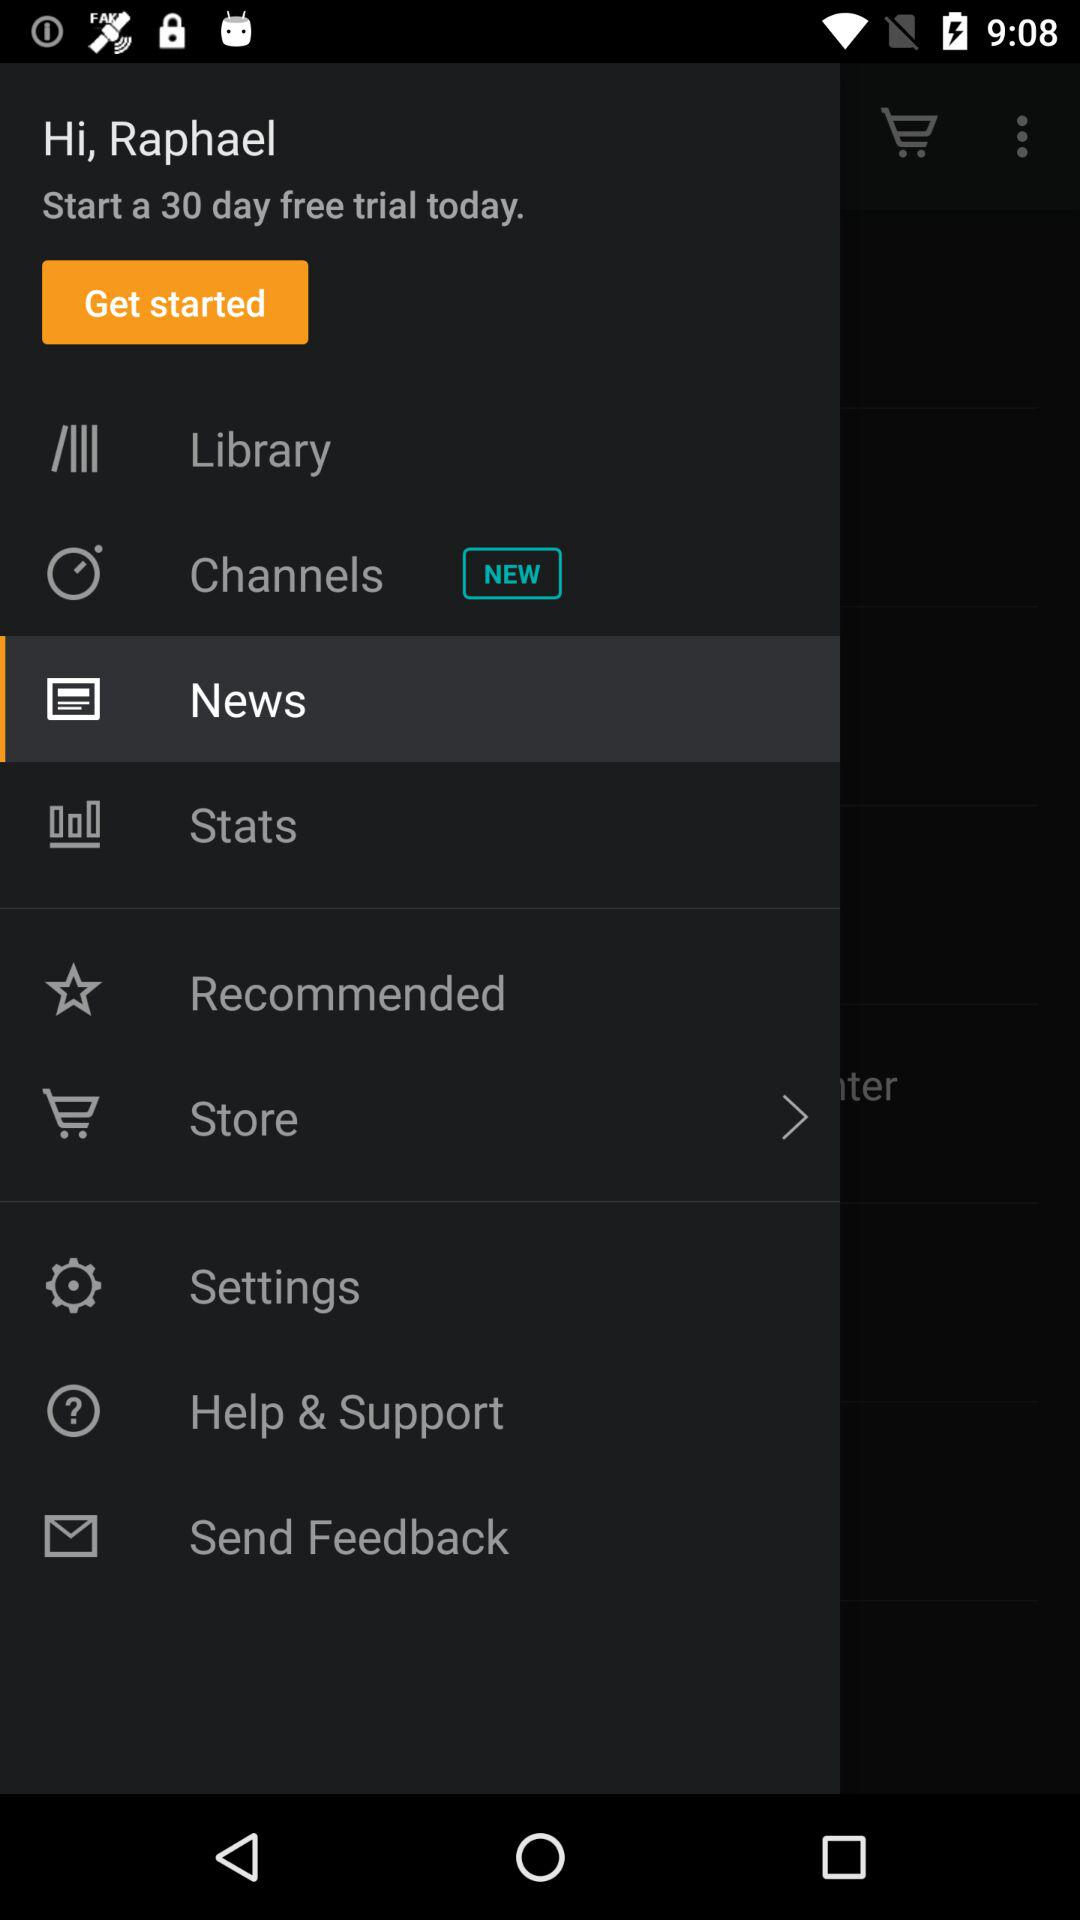Which item is selected? The selected item is "News". 